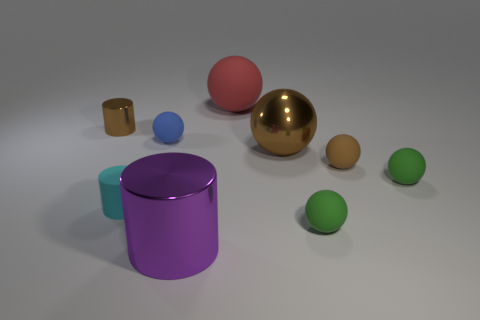Is the large metal sphere the same color as the small metallic object?
Your answer should be compact. Yes. What shape is the large thing in front of the large metal object behind the big metallic cylinder?
Provide a succinct answer. Cylinder. What shape is the green thing that is behind the cyan rubber cylinder in front of the metal thing right of the large metallic cylinder?
Keep it short and to the point. Sphere. What number of objects are small spheres that are right of the tiny blue rubber object or things that are on the left side of the cyan rubber object?
Provide a succinct answer. 4. Does the cyan rubber cylinder have the same size as the brown shiny object to the right of the large rubber object?
Make the answer very short. No. Are the tiny ball on the left side of the purple object and the big sphere right of the large red ball made of the same material?
Give a very brief answer. No. Are there an equal number of cyan matte things left of the tiny matte cylinder and cylinders that are in front of the big brown sphere?
Give a very brief answer. No. How many tiny rubber balls have the same color as the small metal thing?
Offer a very short reply. 1. There is a tiny sphere that is the same color as the large shiny sphere; what material is it?
Offer a very short reply. Rubber. How many rubber objects are either cyan things or big yellow balls?
Offer a very short reply. 1. 